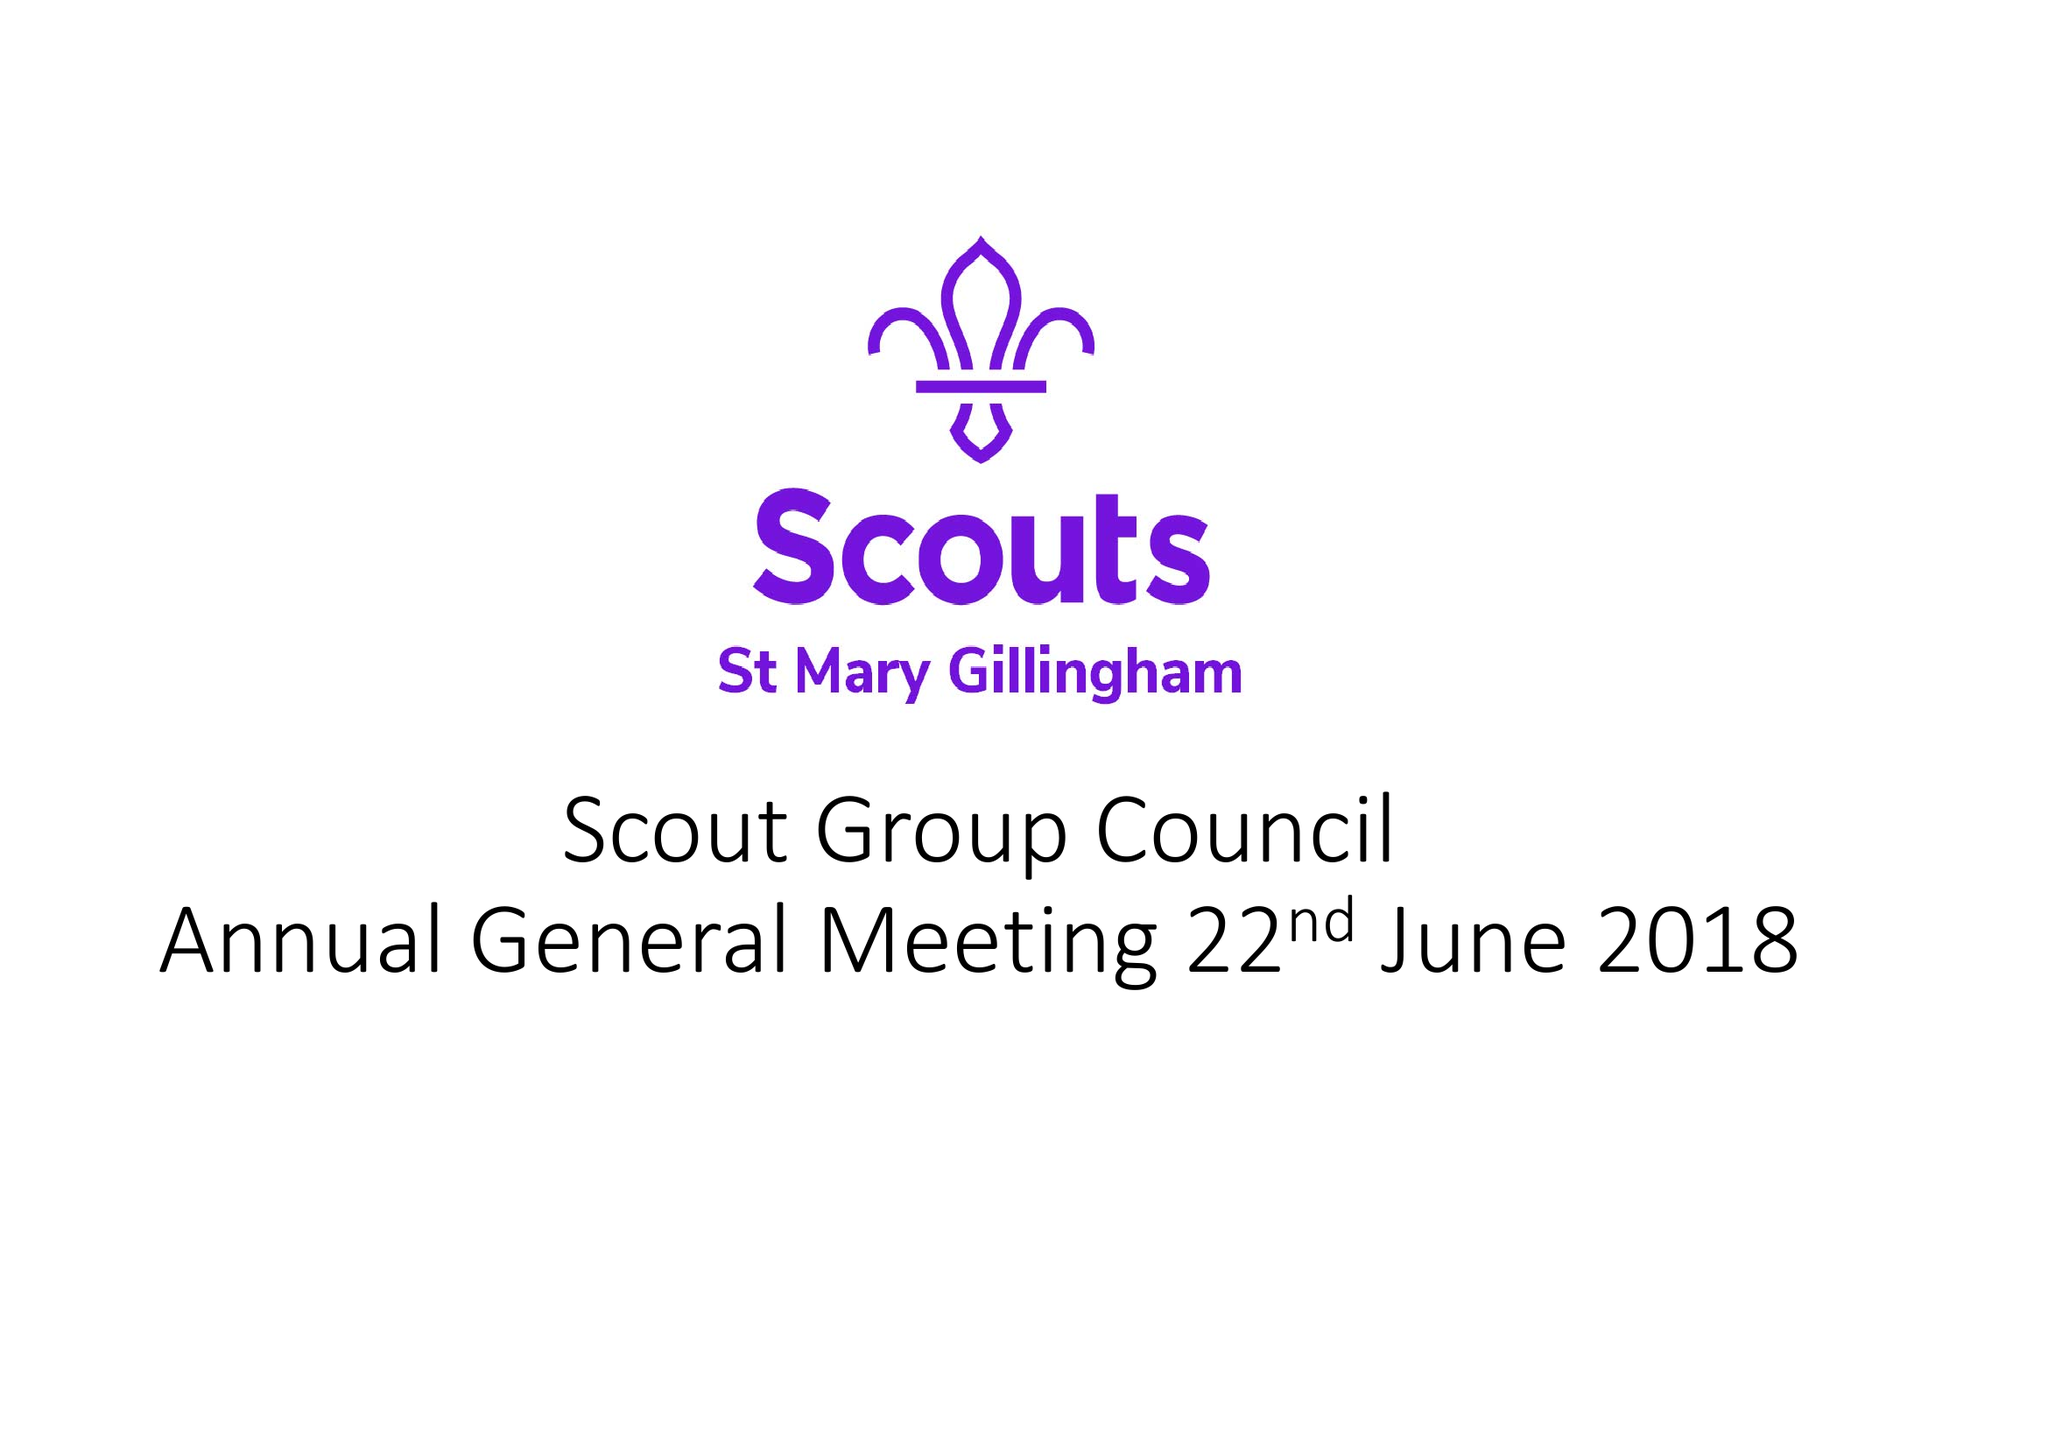What is the value for the income_annually_in_british_pounds?
Answer the question using a single word or phrase. 44658.49 